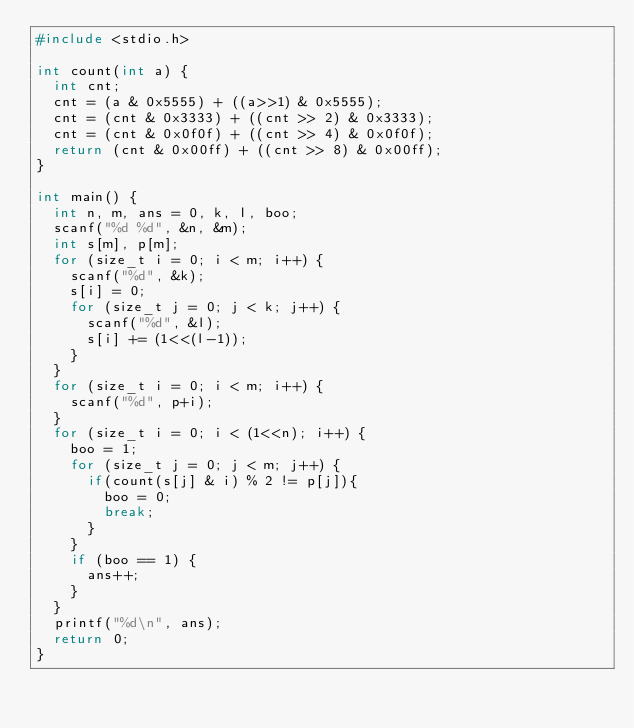Convert code to text. <code><loc_0><loc_0><loc_500><loc_500><_C_>#include <stdio.h>

int count(int a) {
  int cnt;
  cnt = (a & 0x5555) + ((a>>1) & 0x5555);
  cnt = (cnt & 0x3333) + ((cnt >> 2) & 0x3333);
  cnt = (cnt & 0x0f0f) + ((cnt >> 4) & 0x0f0f);
  return (cnt & 0x00ff) + ((cnt >> 8) & 0x00ff);
}

int main() {
  int n, m, ans = 0, k, l, boo;
  scanf("%d %d", &n, &m);
  int s[m], p[m];
  for (size_t i = 0; i < m; i++) {
    scanf("%d", &k);
    s[i] = 0;
    for (size_t j = 0; j < k; j++) {
      scanf("%d", &l);
      s[i] += (1<<(l-1));
    }
  }
  for (size_t i = 0; i < m; i++) {
    scanf("%d", p+i);
  }
  for (size_t i = 0; i < (1<<n); i++) {
    boo = 1;
    for (size_t j = 0; j < m; j++) {
      if(count(s[j] & i) % 2 != p[j]){
        boo = 0;
        break;
      }
    }
    if (boo == 1) {
      ans++;
    }
  }
  printf("%d\n", ans);
  return 0;
}
</code> 